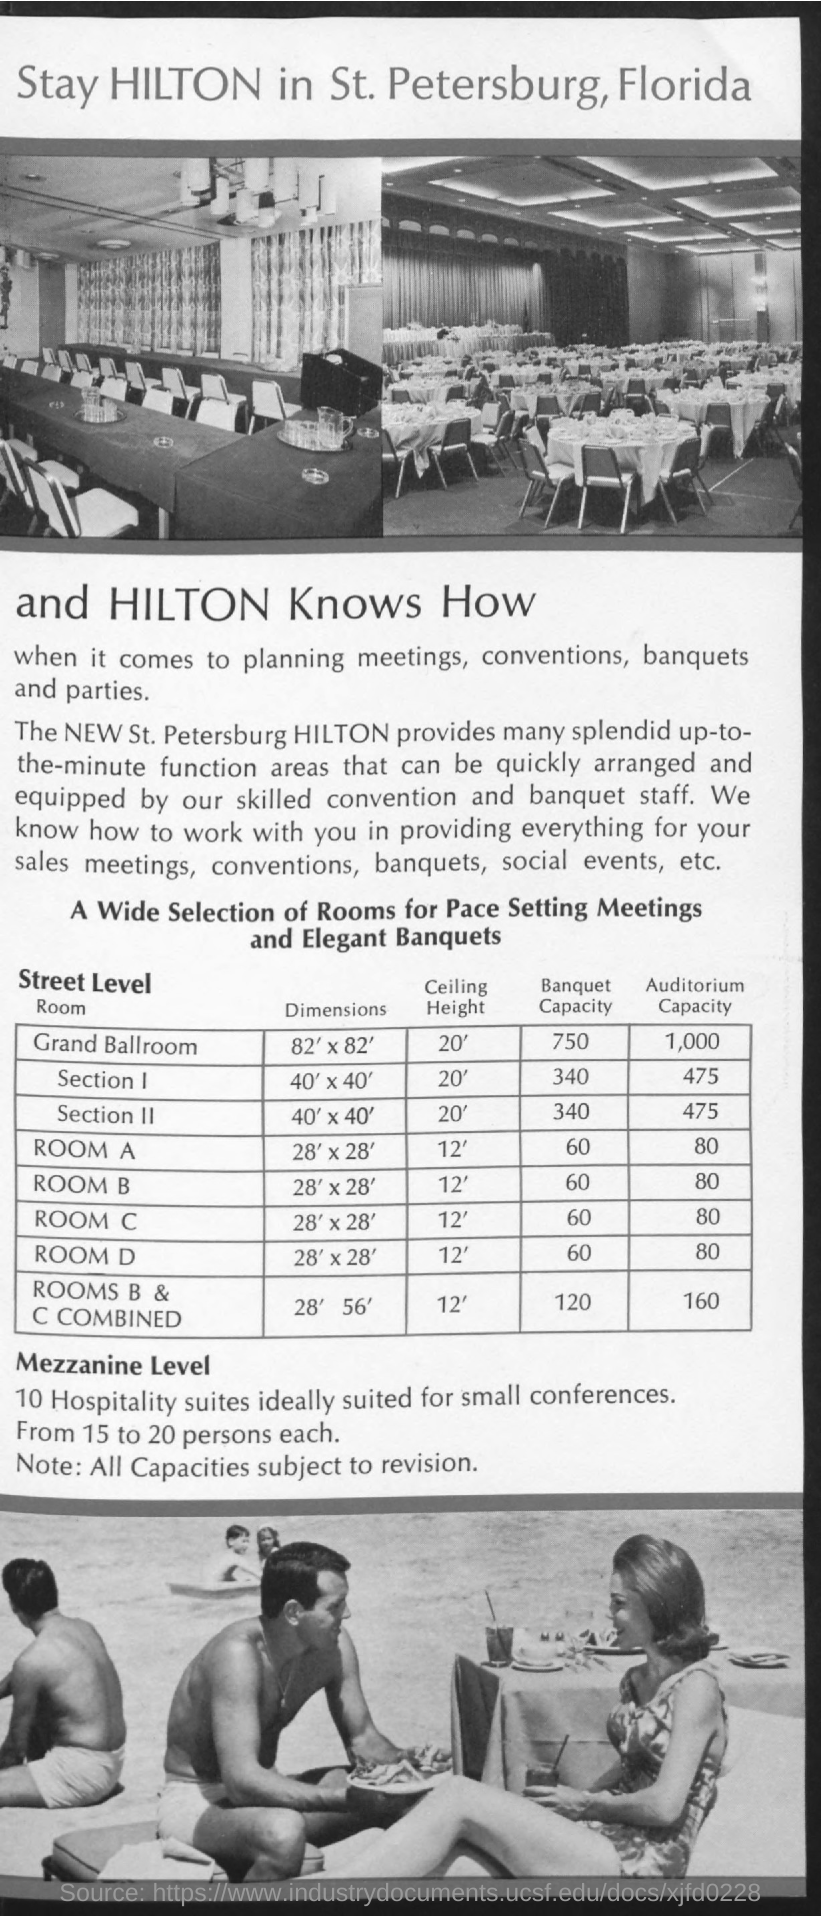What is the ceiling height of the rooms listed on Street Level? All rooms listed on Street Level, including the Grand Ballroom, Sections I and II, and Rooms A through D, feature a ceiling height of 12 feet. This height provides a spacious atmosphere for events, and the uniform measurement suggests a harmonious design across the different spaces. 